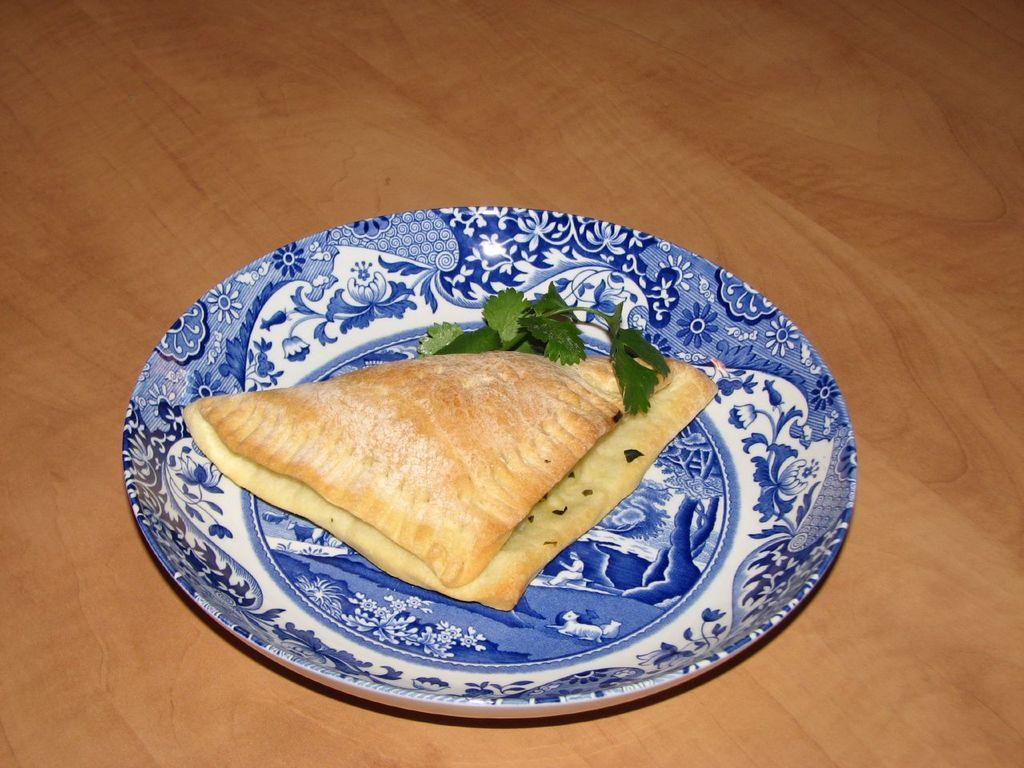How would you summarize this image in a sentence or two? In this image there is a plate on the wooden material. On plate there is some bread and a leafy vegetable are on it 